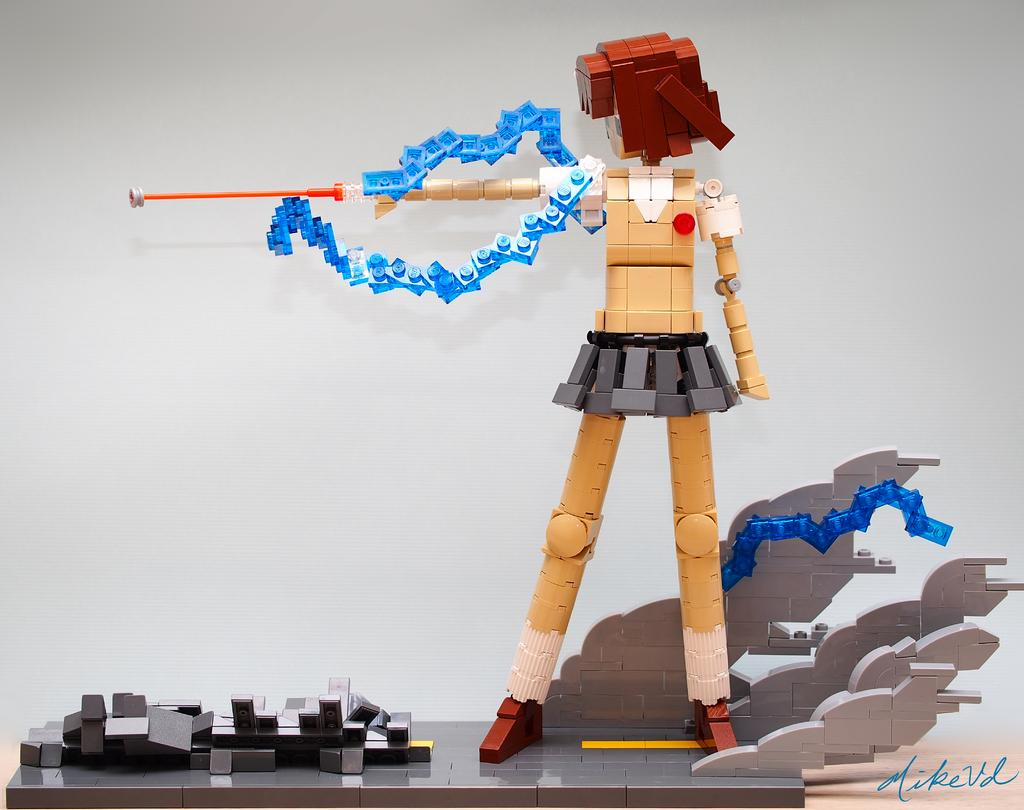What is the main subject of the picture? The main subject of the picture is a Lego. Is there any text present in the image? Yes, there is text in the bottom right corner of the image. What color is the background of the image? The background of the image is white. What type of secretary is shown working in the image? There is no secretary present in the image; it features a Lego and text on a white background. How is the zinc being used in the image? There is no zinc present in the image. 